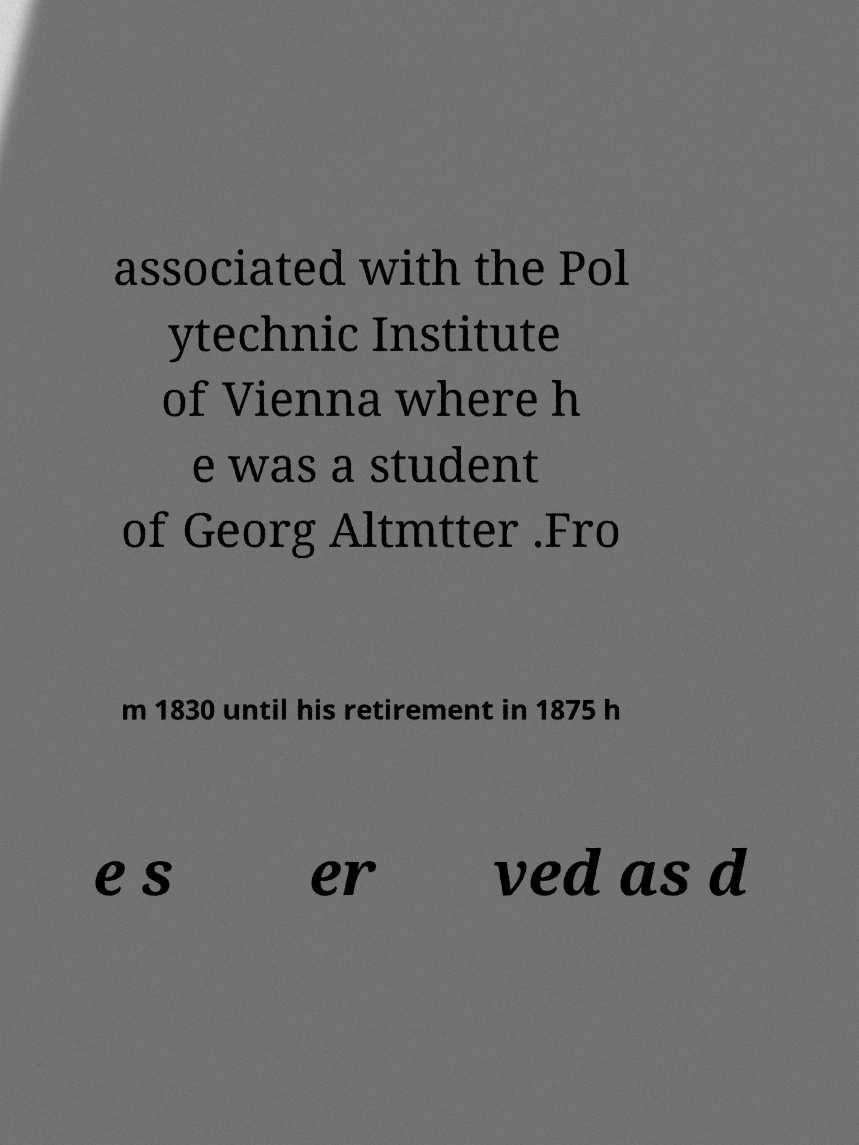Could you assist in decoding the text presented in this image and type it out clearly? associated with the Pol ytechnic Institute of Vienna where h e was a student of Georg Altmtter .Fro m 1830 until his retirement in 1875 h e s er ved as d 